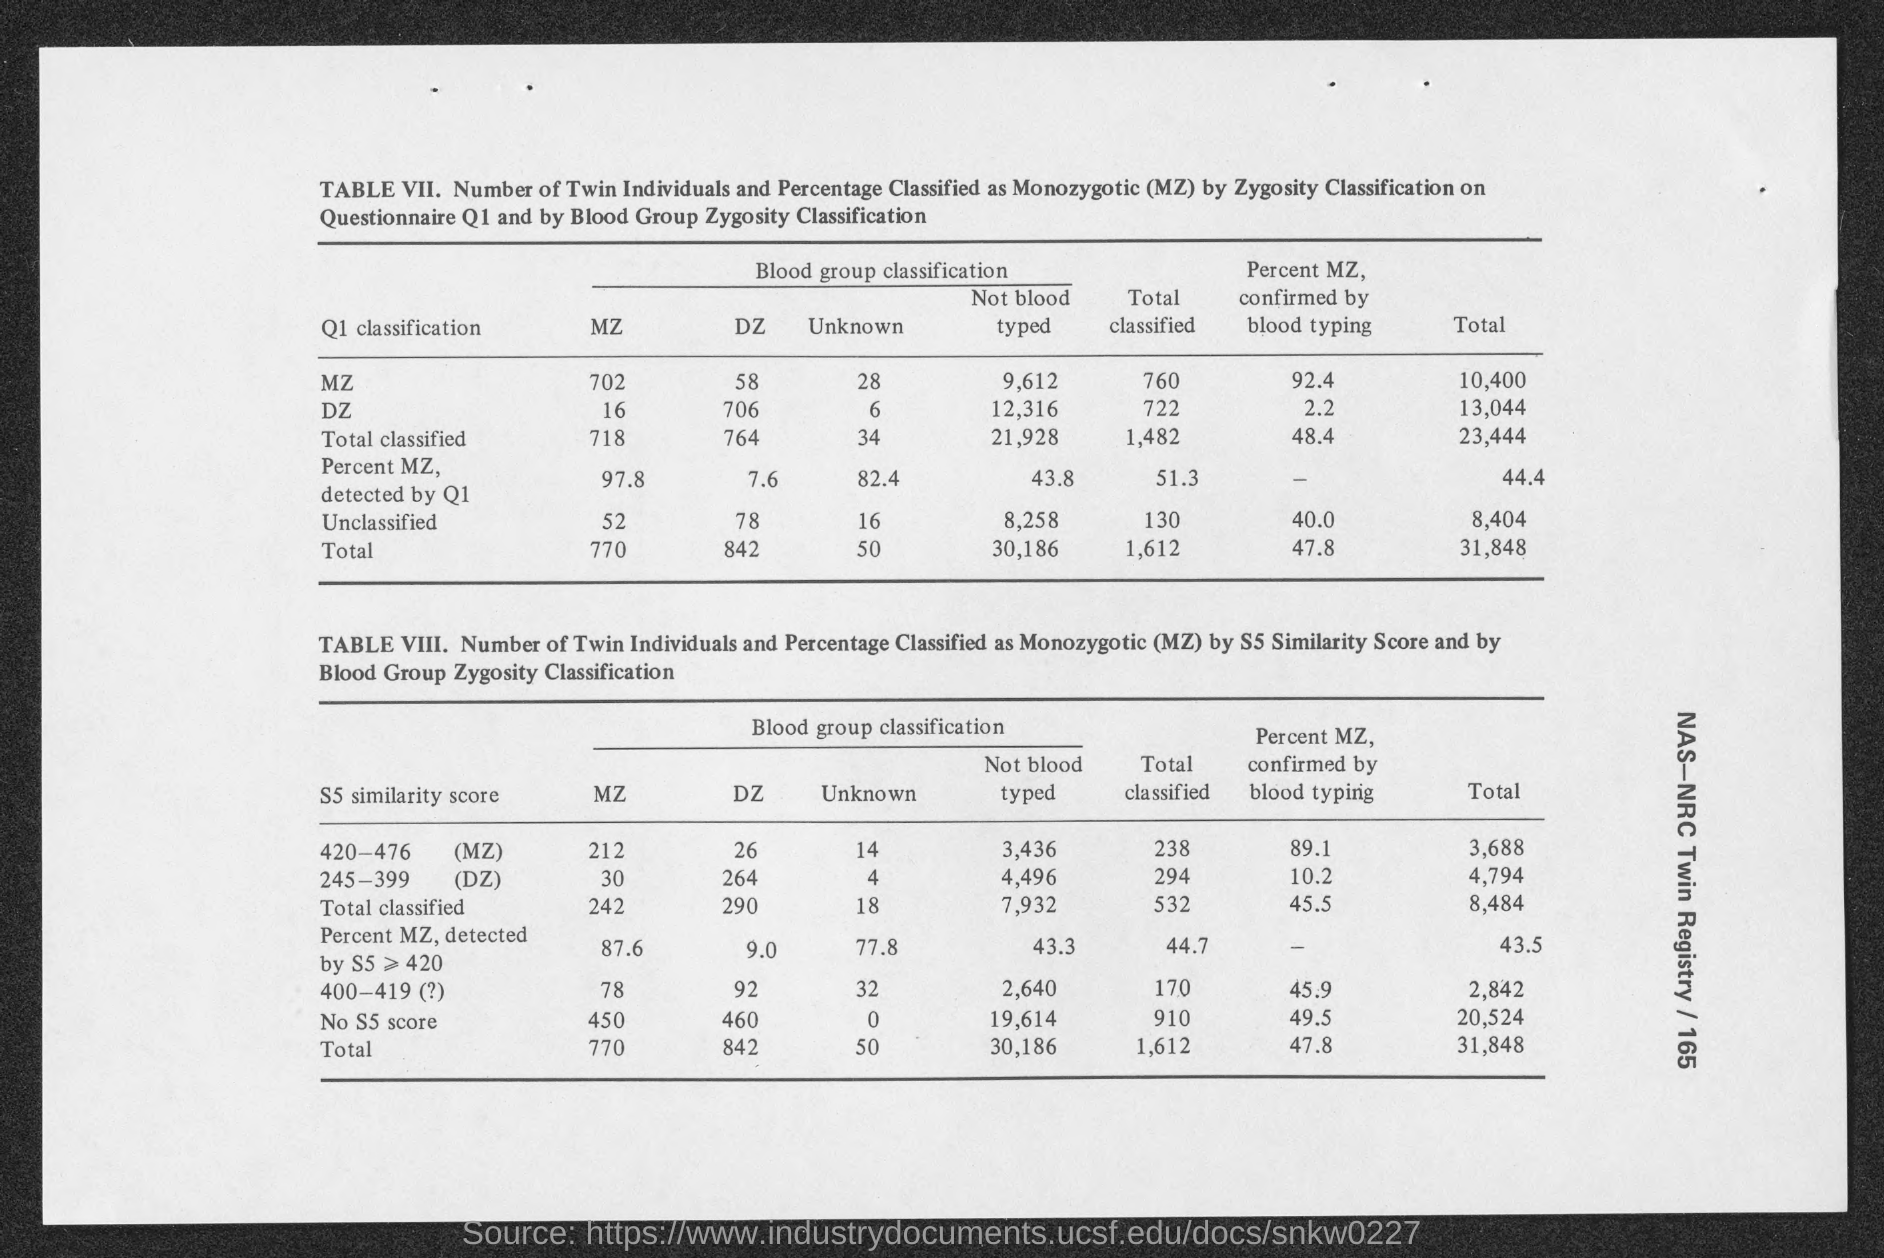Outline some significant characteristics in this image. MZ" refers to monozygotic twins, where two fetuses develop from a single zygote that splits into two embryos during the early stages of pregnancy. The first classification listed on Table VII is "Q1. 